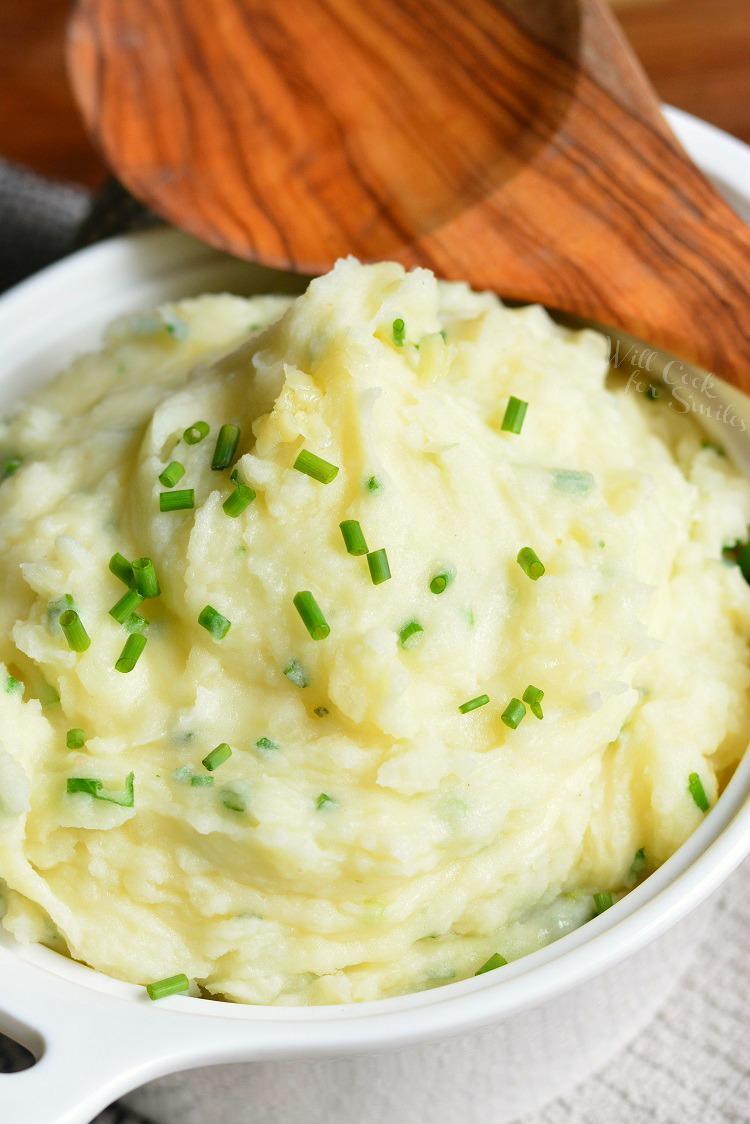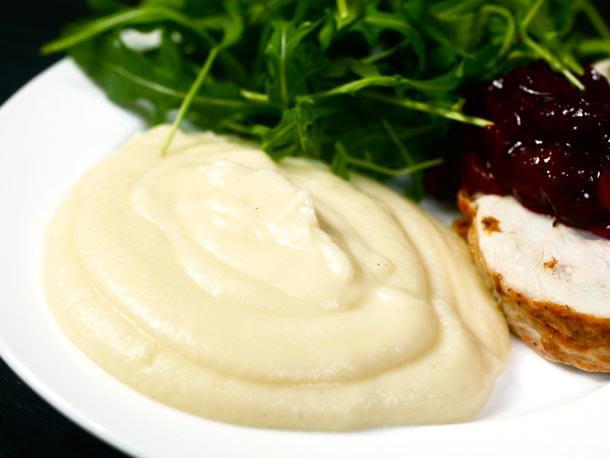The first image is the image on the left, the second image is the image on the right. Examine the images to the left and right. Is the description "The left and right image contains the same number of mash potatoes and chive bowls." accurate? Answer yes or no. No. 